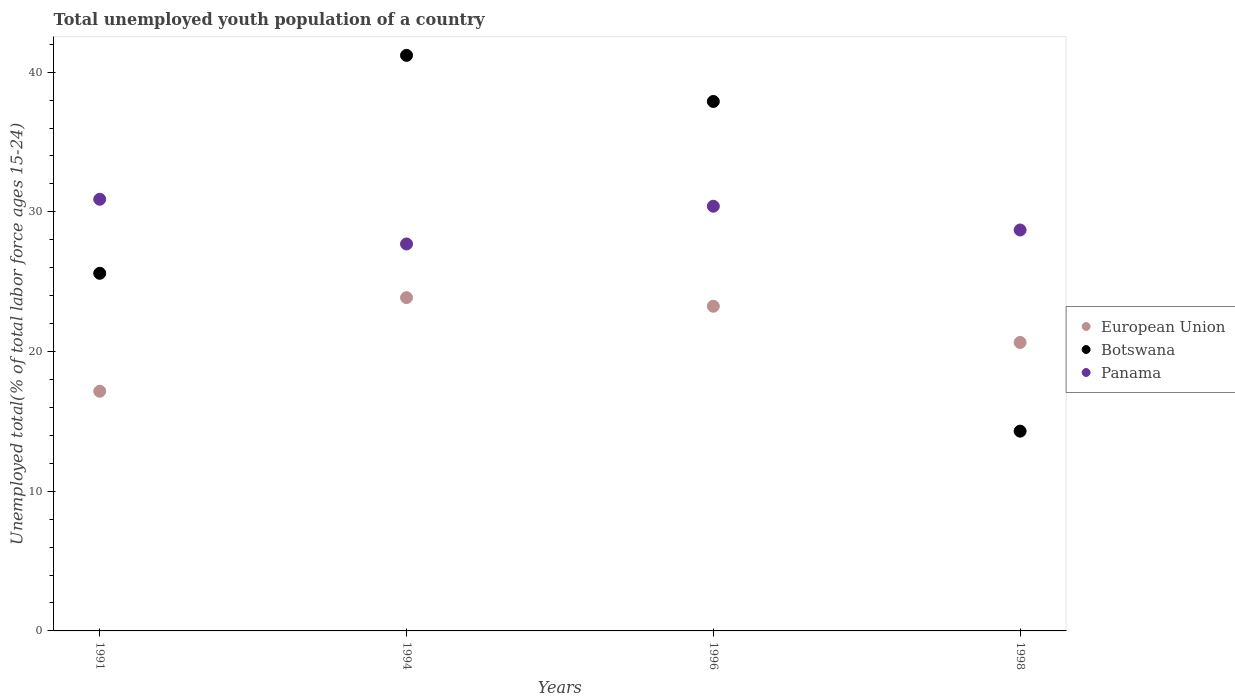How many different coloured dotlines are there?
Your response must be concise. 3. What is the percentage of total unemployed youth population of a country in Panama in 1994?
Your answer should be very brief. 27.7. Across all years, what is the maximum percentage of total unemployed youth population of a country in Botswana?
Keep it short and to the point. 41.2. Across all years, what is the minimum percentage of total unemployed youth population of a country in Botswana?
Ensure brevity in your answer.  14.3. In which year was the percentage of total unemployed youth population of a country in Botswana minimum?
Offer a very short reply. 1998. What is the total percentage of total unemployed youth population of a country in Botswana in the graph?
Ensure brevity in your answer.  119. What is the difference between the percentage of total unemployed youth population of a country in Botswana in 1991 and that in 1996?
Give a very brief answer. -12.3. What is the difference between the percentage of total unemployed youth population of a country in Botswana in 1998 and the percentage of total unemployed youth population of a country in Panama in 1996?
Offer a very short reply. -16.1. What is the average percentage of total unemployed youth population of a country in Botswana per year?
Provide a succinct answer. 29.75. In the year 1998, what is the difference between the percentage of total unemployed youth population of a country in Panama and percentage of total unemployed youth population of a country in European Union?
Offer a very short reply. 8.05. In how many years, is the percentage of total unemployed youth population of a country in Panama greater than 8 %?
Offer a terse response. 4. What is the ratio of the percentage of total unemployed youth population of a country in European Union in 1991 to that in 1998?
Keep it short and to the point. 0.83. What is the difference between the highest and the second highest percentage of total unemployed youth population of a country in Botswana?
Keep it short and to the point. 3.3. What is the difference between the highest and the lowest percentage of total unemployed youth population of a country in Botswana?
Your answer should be compact. 26.9. In how many years, is the percentage of total unemployed youth population of a country in Panama greater than the average percentage of total unemployed youth population of a country in Panama taken over all years?
Your response must be concise. 2. Is it the case that in every year, the sum of the percentage of total unemployed youth population of a country in Panama and percentage of total unemployed youth population of a country in Botswana  is greater than the percentage of total unemployed youth population of a country in European Union?
Make the answer very short. Yes. Does the percentage of total unemployed youth population of a country in Panama monotonically increase over the years?
Offer a very short reply. No. How many dotlines are there?
Offer a very short reply. 3. What is the difference between two consecutive major ticks on the Y-axis?
Provide a succinct answer. 10. Does the graph contain grids?
Your response must be concise. No. Where does the legend appear in the graph?
Your answer should be compact. Center right. How are the legend labels stacked?
Ensure brevity in your answer.  Vertical. What is the title of the graph?
Make the answer very short. Total unemployed youth population of a country. Does "Turks and Caicos Islands" appear as one of the legend labels in the graph?
Provide a short and direct response. No. What is the label or title of the X-axis?
Provide a short and direct response. Years. What is the label or title of the Y-axis?
Keep it short and to the point. Unemployed total(% of total labor force ages 15-24). What is the Unemployed total(% of total labor force ages 15-24) of European Union in 1991?
Provide a short and direct response. 17.16. What is the Unemployed total(% of total labor force ages 15-24) of Botswana in 1991?
Ensure brevity in your answer.  25.6. What is the Unemployed total(% of total labor force ages 15-24) in Panama in 1991?
Provide a succinct answer. 30.9. What is the Unemployed total(% of total labor force ages 15-24) in European Union in 1994?
Your response must be concise. 23.86. What is the Unemployed total(% of total labor force ages 15-24) of Botswana in 1994?
Provide a succinct answer. 41.2. What is the Unemployed total(% of total labor force ages 15-24) of Panama in 1994?
Offer a very short reply. 27.7. What is the Unemployed total(% of total labor force ages 15-24) in European Union in 1996?
Provide a short and direct response. 23.24. What is the Unemployed total(% of total labor force ages 15-24) of Botswana in 1996?
Make the answer very short. 37.9. What is the Unemployed total(% of total labor force ages 15-24) of Panama in 1996?
Keep it short and to the point. 30.4. What is the Unemployed total(% of total labor force ages 15-24) in European Union in 1998?
Provide a succinct answer. 20.65. What is the Unemployed total(% of total labor force ages 15-24) of Botswana in 1998?
Keep it short and to the point. 14.3. What is the Unemployed total(% of total labor force ages 15-24) in Panama in 1998?
Provide a succinct answer. 28.7. Across all years, what is the maximum Unemployed total(% of total labor force ages 15-24) of European Union?
Provide a short and direct response. 23.86. Across all years, what is the maximum Unemployed total(% of total labor force ages 15-24) in Botswana?
Ensure brevity in your answer.  41.2. Across all years, what is the maximum Unemployed total(% of total labor force ages 15-24) in Panama?
Offer a very short reply. 30.9. Across all years, what is the minimum Unemployed total(% of total labor force ages 15-24) in European Union?
Your response must be concise. 17.16. Across all years, what is the minimum Unemployed total(% of total labor force ages 15-24) of Botswana?
Keep it short and to the point. 14.3. Across all years, what is the minimum Unemployed total(% of total labor force ages 15-24) in Panama?
Offer a very short reply. 27.7. What is the total Unemployed total(% of total labor force ages 15-24) of European Union in the graph?
Make the answer very short. 84.91. What is the total Unemployed total(% of total labor force ages 15-24) in Botswana in the graph?
Offer a very short reply. 119. What is the total Unemployed total(% of total labor force ages 15-24) in Panama in the graph?
Provide a succinct answer. 117.7. What is the difference between the Unemployed total(% of total labor force ages 15-24) of European Union in 1991 and that in 1994?
Provide a short and direct response. -6.7. What is the difference between the Unemployed total(% of total labor force ages 15-24) in Botswana in 1991 and that in 1994?
Your answer should be compact. -15.6. What is the difference between the Unemployed total(% of total labor force ages 15-24) in European Union in 1991 and that in 1996?
Make the answer very short. -6.09. What is the difference between the Unemployed total(% of total labor force ages 15-24) in Panama in 1991 and that in 1996?
Your answer should be compact. 0.5. What is the difference between the Unemployed total(% of total labor force ages 15-24) of European Union in 1991 and that in 1998?
Make the answer very short. -3.49. What is the difference between the Unemployed total(% of total labor force ages 15-24) of Botswana in 1991 and that in 1998?
Keep it short and to the point. 11.3. What is the difference between the Unemployed total(% of total labor force ages 15-24) in Panama in 1991 and that in 1998?
Your answer should be compact. 2.2. What is the difference between the Unemployed total(% of total labor force ages 15-24) of European Union in 1994 and that in 1996?
Give a very brief answer. 0.62. What is the difference between the Unemployed total(% of total labor force ages 15-24) of Panama in 1994 and that in 1996?
Offer a terse response. -2.7. What is the difference between the Unemployed total(% of total labor force ages 15-24) in European Union in 1994 and that in 1998?
Your response must be concise. 3.21. What is the difference between the Unemployed total(% of total labor force ages 15-24) in Botswana in 1994 and that in 1998?
Your answer should be compact. 26.9. What is the difference between the Unemployed total(% of total labor force ages 15-24) of Panama in 1994 and that in 1998?
Offer a terse response. -1. What is the difference between the Unemployed total(% of total labor force ages 15-24) in European Union in 1996 and that in 1998?
Give a very brief answer. 2.59. What is the difference between the Unemployed total(% of total labor force ages 15-24) of Botswana in 1996 and that in 1998?
Ensure brevity in your answer.  23.6. What is the difference between the Unemployed total(% of total labor force ages 15-24) of Panama in 1996 and that in 1998?
Provide a short and direct response. 1.7. What is the difference between the Unemployed total(% of total labor force ages 15-24) of European Union in 1991 and the Unemployed total(% of total labor force ages 15-24) of Botswana in 1994?
Provide a short and direct response. -24.04. What is the difference between the Unemployed total(% of total labor force ages 15-24) of European Union in 1991 and the Unemployed total(% of total labor force ages 15-24) of Panama in 1994?
Your answer should be compact. -10.54. What is the difference between the Unemployed total(% of total labor force ages 15-24) in European Union in 1991 and the Unemployed total(% of total labor force ages 15-24) in Botswana in 1996?
Make the answer very short. -20.74. What is the difference between the Unemployed total(% of total labor force ages 15-24) of European Union in 1991 and the Unemployed total(% of total labor force ages 15-24) of Panama in 1996?
Keep it short and to the point. -13.24. What is the difference between the Unemployed total(% of total labor force ages 15-24) of European Union in 1991 and the Unemployed total(% of total labor force ages 15-24) of Botswana in 1998?
Your response must be concise. 2.86. What is the difference between the Unemployed total(% of total labor force ages 15-24) of European Union in 1991 and the Unemployed total(% of total labor force ages 15-24) of Panama in 1998?
Your answer should be compact. -11.54. What is the difference between the Unemployed total(% of total labor force ages 15-24) of European Union in 1994 and the Unemployed total(% of total labor force ages 15-24) of Botswana in 1996?
Ensure brevity in your answer.  -14.04. What is the difference between the Unemployed total(% of total labor force ages 15-24) in European Union in 1994 and the Unemployed total(% of total labor force ages 15-24) in Panama in 1996?
Provide a succinct answer. -6.54. What is the difference between the Unemployed total(% of total labor force ages 15-24) in European Union in 1994 and the Unemployed total(% of total labor force ages 15-24) in Botswana in 1998?
Your response must be concise. 9.56. What is the difference between the Unemployed total(% of total labor force ages 15-24) of European Union in 1994 and the Unemployed total(% of total labor force ages 15-24) of Panama in 1998?
Offer a terse response. -4.84. What is the difference between the Unemployed total(% of total labor force ages 15-24) of European Union in 1996 and the Unemployed total(% of total labor force ages 15-24) of Botswana in 1998?
Give a very brief answer. 8.94. What is the difference between the Unemployed total(% of total labor force ages 15-24) in European Union in 1996 and the Unemployed total(% of total labor force ages 15-24) in Panama in 1998?
Offer a terse response. -5.46. What is the average Unemployed total(% of total labor force ages 15-24) of European Union per year?
Your answer should be very brief. 21.23. What is the average Unemployed total(% of total labor force ages 15-24) in Botswana per year?
Provide a short and direct response. 29.75. What is the average Unemployed total(% of total labor force ages 15-24) of Panama per year?
Provide a short and direct response. 29.43. In the year 1991, what is the difference between the Unemployed total(% of total labor force ages 15-24) in European Union and Unemployed total(% of total labor force ages 15-24) in Botswana?
Provide a succinct answer. -8.44. In the year 1991, what is the difference between the Unemployed total(% of total labor force ages 15-24) of European Union and Unemployed total(% of total labor force ages 15-24) of Panama?
Offer a very short reply. -13.74. In the year 1991, what is the difference between the Unemployed total(% of total labor force ages 15-24) in Botswana and Unemployed total(% of total labor force ages 15-24) in Panama?
Keep it short and to the point. -5.3. In the year 1994, what is the difference between the Unemployed total(% of total labor force ages 15-24) in European Union and Unemployed total(% of total labor force ages 15-24) in Botswana?
Keep it short and to the point. -17.34. In the year 1994, what is the difference between the Unemployed total(% of total labor force ages 15-24) in European Union and Unemployed total(% of total labor force ages 15-24) in Panama?
Your answer should be compact. -3.84. In the year 1996, what is the difference between the Unemployed total(% of total labor force ages 15-24) of European Union and Unemployed total(% of total labor force ages 15-24) of Botswana?
Provide a succinct answer. -14.66. In the year 1996, what is the difference between the Unemployed total(% of total labor force ages 15-24) of European Union and Unemployed total(% of total labor force ages 15-24) of Panama?
Provide a short and direct response. -7.16. In the year 1996, what is the difference between the Unemployed total(% of total labor force ages 15-24) in Botswana and Unemployed total(% of total labor force ages 15-24) in Panama?
Make the answer very short. 7.5. In the year 1998, what is the difference between the Unemployed total(% of total labor force ages 15-24) in European Union and Unemployed total(% of total labor force ages 15-24) in Botswana?
Keep it short and to the point. 6.35. In the year 1998, what is the difference between the Unemployed total(% of total labor force ages 15-24) in European Union and Unemployed total(% of total labor force ages 15-24) in Panama?
Give a very brief answer. -8.05. In the year 1998, what is the difference between the Unemployed total(% of total labor force ages 15-24) in Botswana and Unemployed total(% of total labor force ages 15-24) in Panama?
Provide a succinct answer. -14.4. What is the ratio of the Unemployed total(% of total labor force ages 15-24) of European Union in 1991 to that in 1994?
Give a very brief answer. 0.72. What is the ratio of the Unemployed total(% of total labor force ages 15-24) of Botswana in 1991 to that in 1994?
Provide a succinct answer. 0.62. What is the ratio of the Unemployed total(% of total labor force ages 15-24) of Panama in 1991 to that in 1994?
Your answer should be very brief. 1.12. What is the ratio of the Unemployed total(% of total labor force ages 15-24) in European Union in 1991 to that in 1996?
Offer a terse response. 0.74. What is the ratio of the Unemployed total(% of total labor force ages 15-24) of Botswana in 1991 to that in 1996?
Keep it short and to the point. 0.68. What is the ratio of the Unemployed total(% of total labor force ages 15-24) of Panama in 1991 to that in 1996?
Your answer should be compact. 1.02. What is the ratio of the Unemployed total(% of total labor force ages 15-24) in European Union in 1991 to that in 1998?
Ensure brevity in your answer.  0.83. What is the ratio of the Unemployed total(% of total labor force ages 15-24) in Botswana in 1991 to that in 1998?
Provide a short and direct response. 1.79. What is the ratio of the Unemployed total(% of total labor force ages 15-24) in Panama in 1991 to that in 1998?
Make the answer very short. 1.08. What is the ratio of the Unemployed total(% of total labor force ages 15-24) in European Union in 1994 to that in 1996?
Ensure brevity in your answer.  1.03. What is the ratio of the Unemployed total(% of total labor force ages 15-24) in Botswana in 1994 to that in 1996?
Keep it short and to the point. 1.09. What is the ratio of the Unemployed total(% of total labor force ages 15-24) of Panama in 1994 to that in 1996?
Ensure brevity in your answer.  0.91. What is the ratio of the Unemployed total(% of total labor force ages 15-24) in European Union in 1994 to that in 1998?
Provide a short and direct response. 1.16. What is the ratio of the Unemployed total(% of total labor force ages 15-24) of Botswana in 1994 to that in 1998?
Offer a very short reply. 2.88. What is the ratio of the Unemployed total(% of total labor force ages 15-24) of Panama in 1994 to that in 1998?
Provide a short and direct response. 0.97. What is the ratio of the Unemployed total(% of total labor force ages 15-24) in European Union in 1996 to that in 1998?
Provide a short and direct response. 1.13. What is the ratio of the Unemployed total(% of total labor force ages 15-24) of Botswana in 1996 to that in 1998?
Offer a terse response. 2.65. What is the ratio of the Unemployed total(% of total labor force ages 15-24) of Panama in 1996 to that in 1998?
Ensure brevity in your answer.  1.06. What is the difference between the highest and the second highest Unemployed total(% of total labor force ages 15-24) of European Union?
Provide a short and direct response. 0.62. What is the difference between the highest and the second highest Unemployed total(% of total labor force ages 15-24) of Botswana?
Your answer should be compact. 3.3. What is the difference between the highest and the lowest Unemployed total(% of total labor force ages 15-24) in European Union?
Ensure brevity in your answer.  6.7. What is the difference between the highest and the lowest Unemployed total(% of total labor force ages 15-24) in Botswana?
Provide a succinct answer. 26.9. 